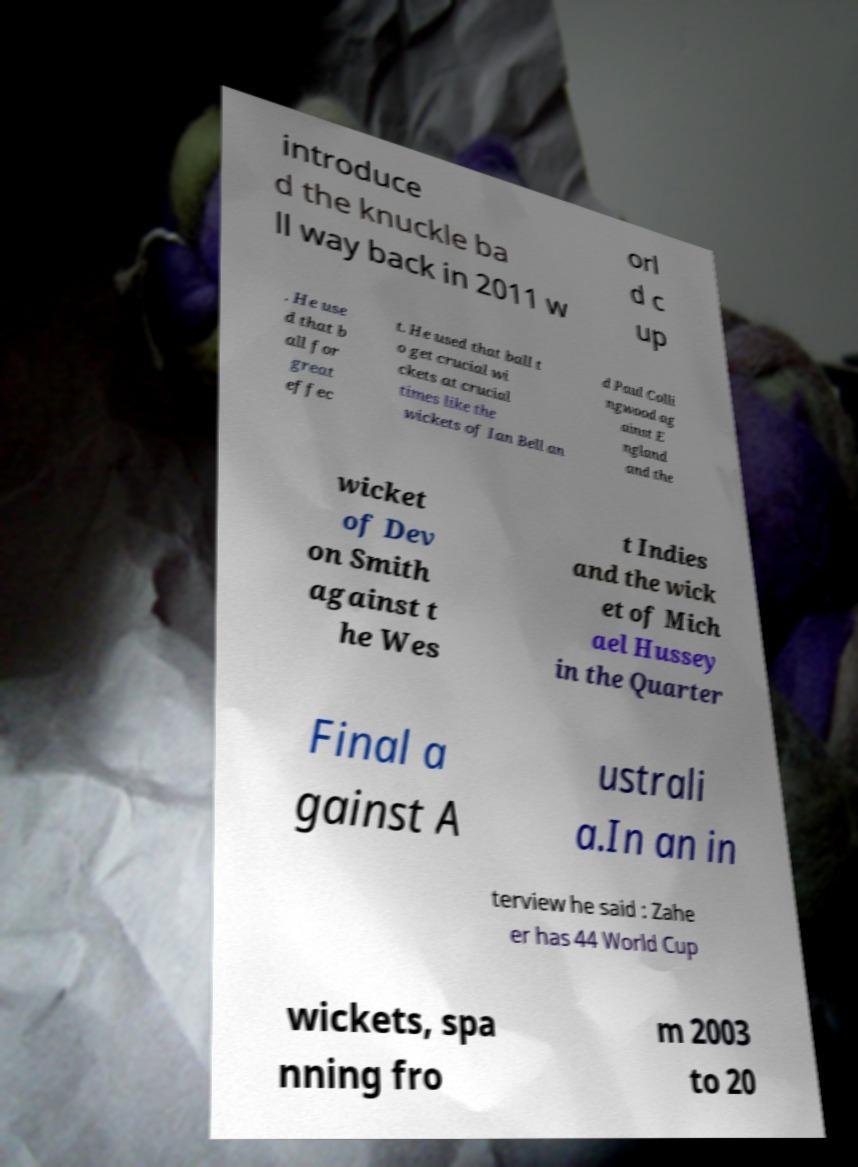Could you extract and type out the text from this image? introduce d the knuckle ba ll way back in 2011 w orl d c up . He use d that b all for great effec t. He used that ball t o get crucial wi ckets at crucial times like the wickets of Ian Bell an d Paul Colli ngwood ag ainst E ngland and the wicket of Dev on Smith against t he Wes t Indies and the wick et of Mich ael Hussey in the Quarter Final a gainst A ustrali a.In an in terview he said : Zahe er has 44 World Cup wickets, spa nning fro m 2003 to 20 